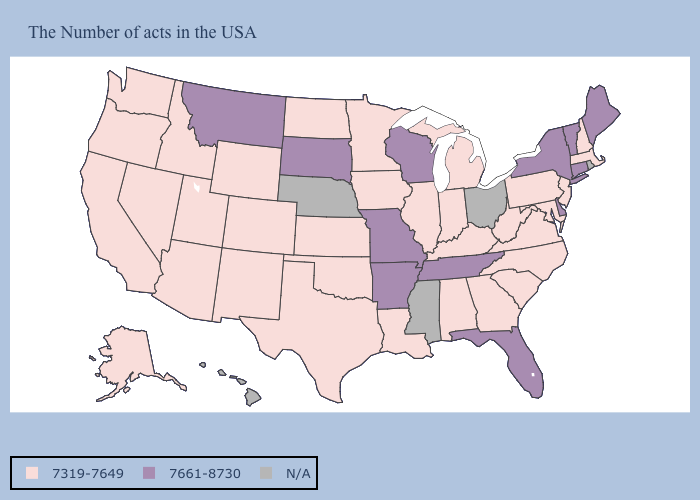Name the states that have a value in the range N/A?
Keep it brief. Rhode Island, Ohio, Mississippi, Nebraska, Hawaii. Does Utah have the highest value in the USA?
Be succinct. No. What is the value of Hawaii?
Keep it brief. N/A. Which states have the lowest value in the USA?
Keep it brief. Massachusetts, New Hampshire, New Jersey, Maryland, Pennsylvania, Virginia, North Carolina, South Carolina, West Virginia, Georgia, Michigan, Kentucky, Indiana, Alabama, Illinois, Louisiana, Minnesota, Iowa, Kansas, Oklahoma, Texas, North Dakota, Wyoming, Colorado, New Mexico, Utah, Arizona, Idaho, Nevada, California, Washington, Oregon, Alaska. Among the states that border Rhode Island , does Massachusetts have the highest value?
Keep it brief. No. Does Kentucky have the highest value in the South?
Give a very brief answer. No. Which states have the lowest value in the MidWest?
Give a very brief answer. Michigan, Indiana, Illinois, Minnesota, Iowa, Kansas, North Dakota. What is the value of North Carolina?
Be succinct. 7319-7649. Which states have the highest value in the USA?
Quick response, please. Maine, Vermont, Connecticut, New York, Delaware, Florida, Tennessee, Wisconsin, Missouri, Arkansas, South Dakota, Montana. Does Washington have the lowest value in the USA?
Give a very brief answer. Yes. What is the highest value in the USA?
Give a very brief answer. 7661-8730. Name the states that have a value in the range N/A?
Write a very short answer. Rhode Island, Ohio, Mississippi, Nebraska, Hawaii. Name the states that have a value in the range 7319-7649?
Concise answer only. Massachusetts, New Hampshire, New Jersey, Maryland, Pennsylvania, Virginia, North Carolina, South Carolina, West Virginia, Georgia, Michigan, Kentucky, Indiana, Alabama, Illinois, Louisiana, Minnesota, Iowa, Kansas, Oklahoma, Texas, North Dakota, Wyoming, Colorado, New Mexico, Utah, Arizona, Idaho, Nevada, California, Washington, Oregon, Alaska. Does Georgia have the lowest value in the South?
Answer briefly. Yes. 